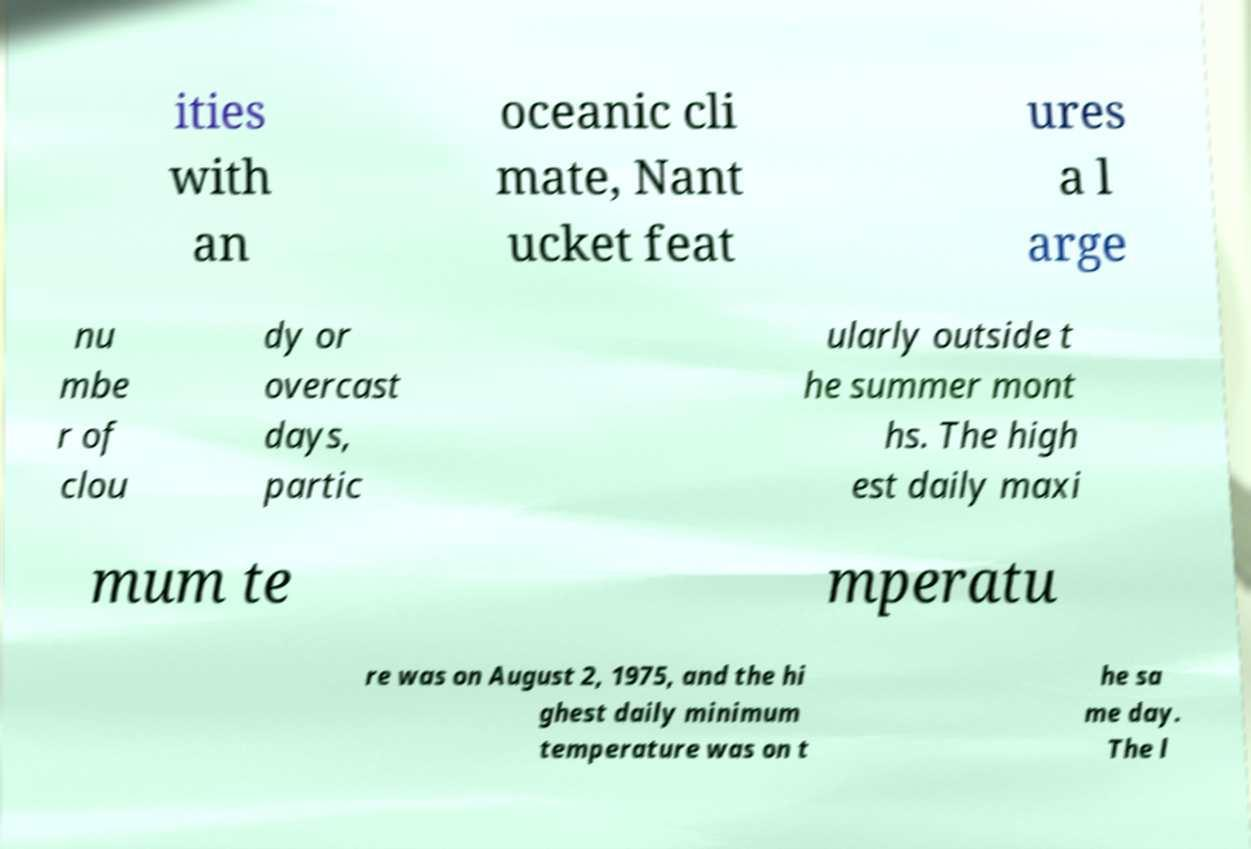Please identify and transcribe the text found in this image. ities with an oceanic cli mate, Nant ucket feat ures a l arge nu mbe r of clou dy or overcast days, partic ularly outside t he summer mont hs. The high est daily maxi mum te mperatu re was on August 2, 1975, and the hi ghest daily minimum temperature was on t he sa me day. The l 